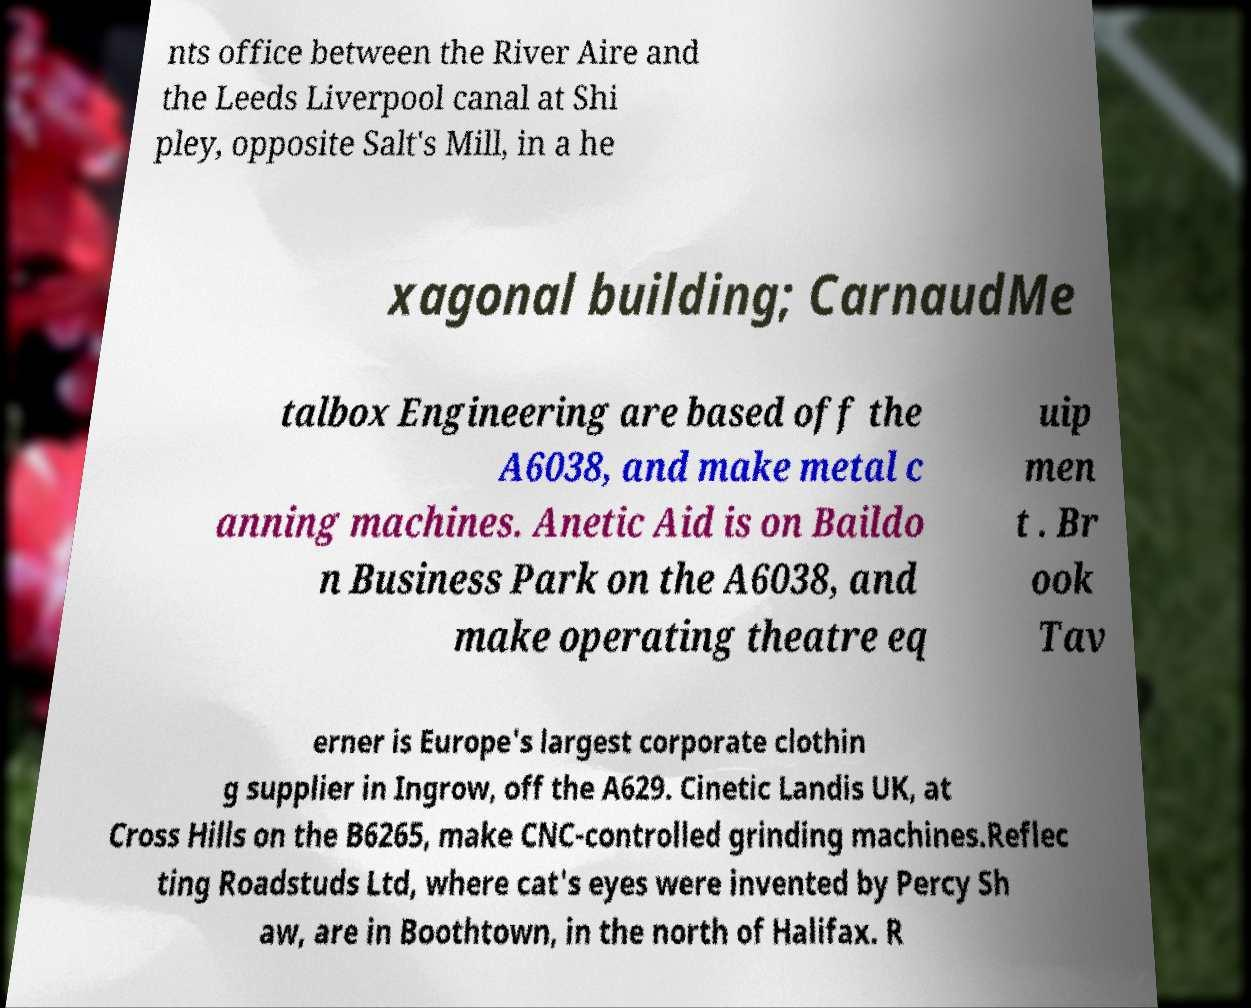Can you accurately transcribe the text from the provided image for me? nts office between the River Aire and the Leeds Liverpool canal at Shi pley, opposite Salt's Mill, in a he xagonal building; CarnaudMe talbox Engineering are based off the A6038, and make metal c anning machines. Anetic Aid is on Baildo n Business Park on the A6038, and make operating theatre eq uip men t . Br ook Tav erner is Europe's largest corporate clothin g supplier in Ingrow, off the A629. Cinetic Landis UK, at Cross Hills on the B6265, make CNC-controlled grinding machines.Reflec ting Roadstuds Ltd, where cat's eyes were invented by Percy Sh aw, are in Boothtown, in the north of Halifax. R 